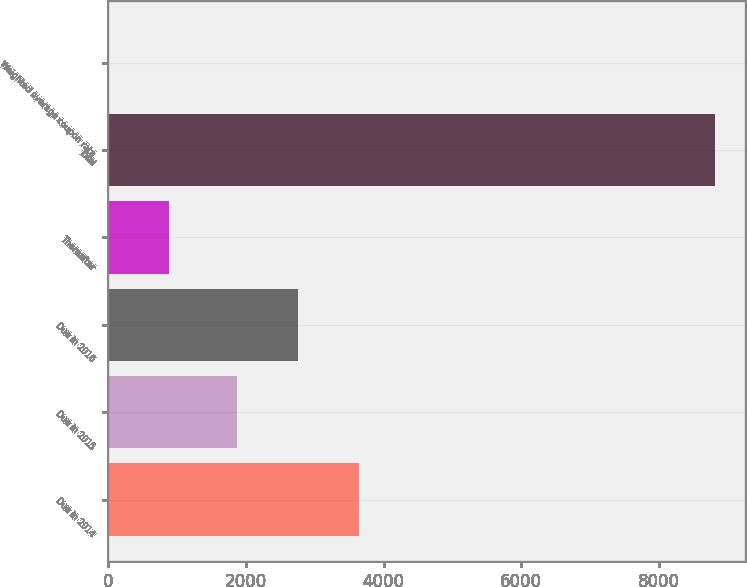<chart> <loc_0><loc_0><loc_500><loc_500><bar_chart><fcel>Due in 2014<fcel>Due in 2015<fcel>Due in 2016<fcel>Thereafter<fcel>Total<fcel>Weighted average coupon rate<nl><fcel>3638.74<fcel>1877<fcel>2757.87<fcel>882.17<fcel>8810<fcel>1.3<nl></chart> 